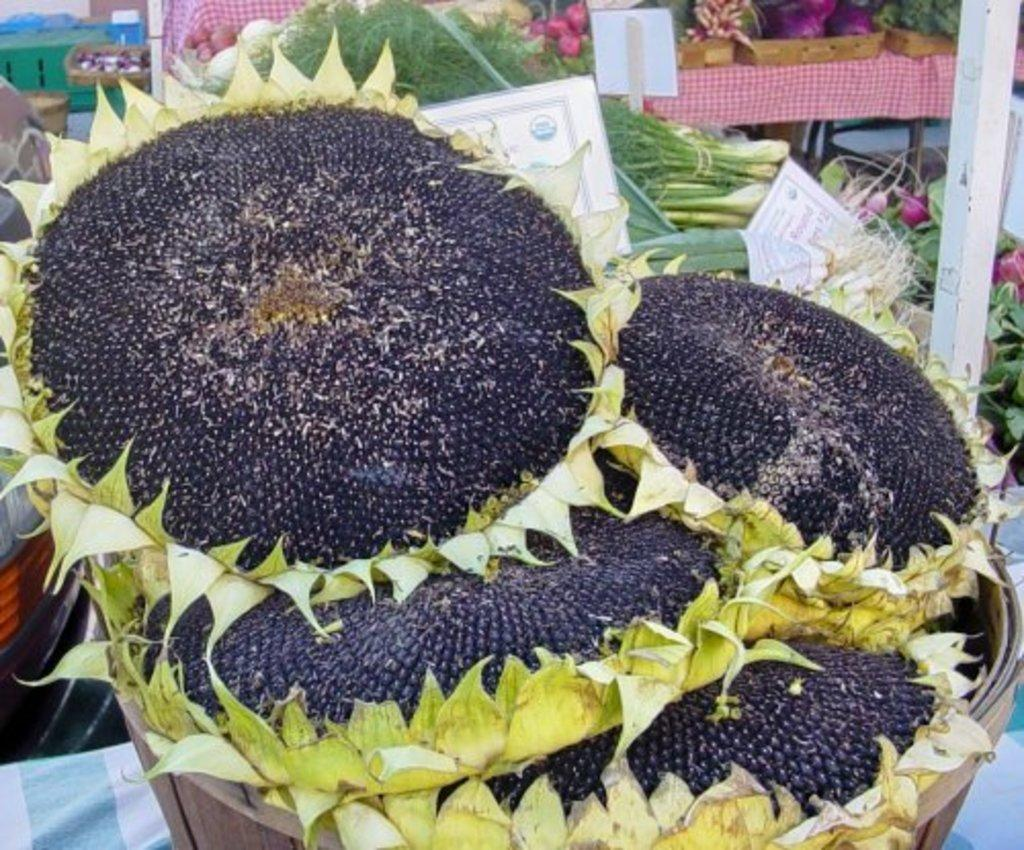What type of plants are in the basket in the image? There are sunflowers planted in a basket in the image. What can be seen in the background of the image? There are vegetables, leafy vegetables, and information boards in the background of the image. What type of engine is being used to power the sunflowers in the image? There is no engine present in the image; the sunflowers are planted in a basket and are not being powered by any engine. 